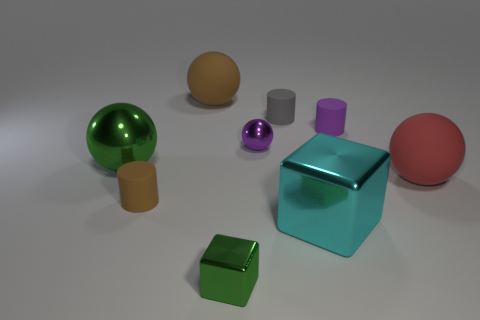Add 1 big green shiny objects. How many objects exist? 10 Subtract all cylinders. How many objects are left? 6 Add 6 big metal spheres. How many big metal spheres are left? 7 Add 2 brown things. How many brown things exist? 4 Subtract 1 gray cylinders. How many objects are left? 8 Subtract all yellow shiny spheres. Subtract all large green metallic objects. How many objects are left? 8 